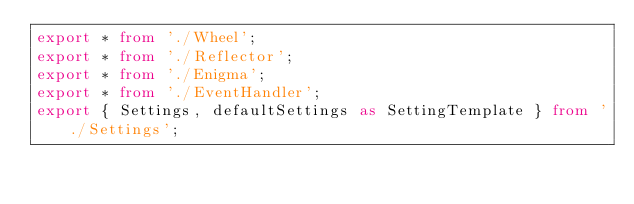Convert code to text. <code><loc_0><loc_0><loc_500><loc_500><_TypeScript_>export * from './Wheel';
export * from './Reflector';
export * from './Enigma';
export * from './EventHandler';
export { Settings, defaultSettings as SettingTemplate } from './Settings';
</code> 